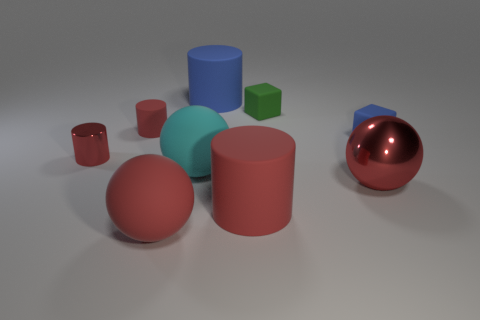There is a large ball right of the big blue matte cylinder; does it have the same color as the big cylinder that is in front of the green block?
Ensure brevity in your answer.  Yes. How many other objects are there of the same color as the big metallic ball?
Offer a very short reply. 4. There is a large cyan object; are there any small cubes on the left side of it?
Provide a short and direct response. No. The large sphere in front of the large red object to the right of the cylinder that is to the right of the big blue cylinder is what color?
Offer a terse response. Red. What shape is the cyan thing that is the same size as the red metal ball?
Provide a succinct answer. Sphere. Are there more metallic balls than big yellow metallic cylinders?
Keep it short and to the point. Yes. There is a red metallic object right of the small red matte cylinder; are there any green objects in front of it?
Provide a short and direct response. No. The other matte thing that is the same shape as the tiny green thing is what color?
Give a very brief answer. Blue. The other big cylinder that is the same material as the large blue cylinder is what color?
Provide a short and direct response. Red. Are there any red metal cylinders that are right of the cylinder that is in front of the red metal cylinder that is in front of the green rubber thing?
Your response must be concise. No. 